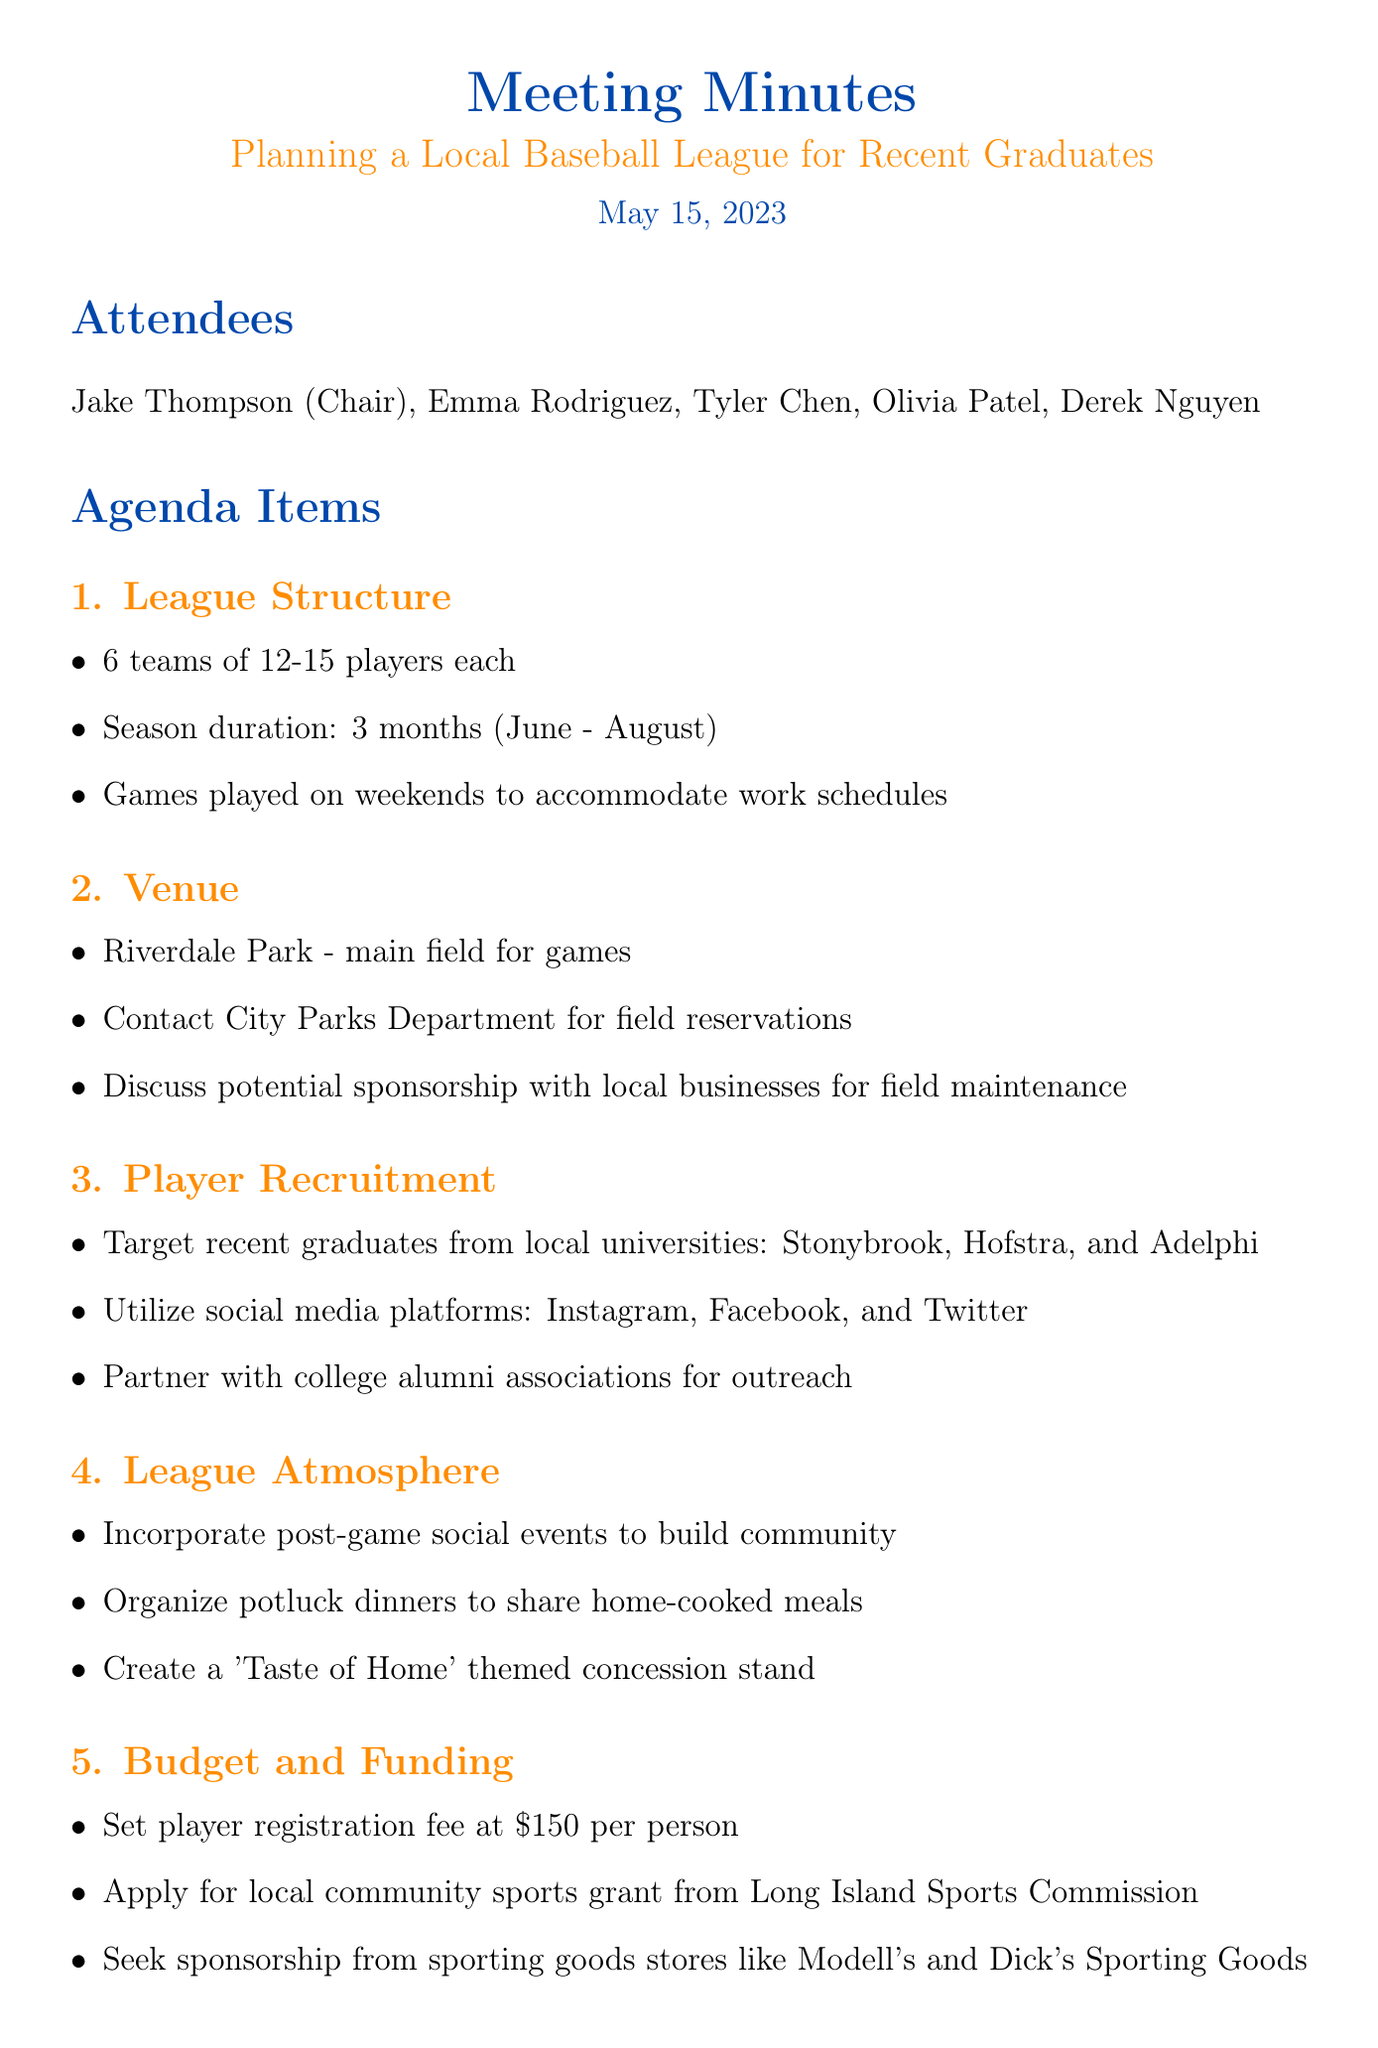What is the title of the meeting? The title of the meeting is specified at the top of the document, which is focused on planning a local baseball league.
Answer: Planning a Local Baseball League for Recent Graduates When will the season last? The document states the season duration, which is outlined in the league structure section.
Answer: 3 months How many players will each team have? The number of players per team is listed under the league structure section of the document.
Answer: 12-15 players Which park will be the main venue for games? The main field for games is mentioned in the venue section of the document.
Answer: Riverdale Park What is the player registration fee? The budget and funding section specifies the fee for players registering for the league.
Answer: $150 Who is responsible for drafting league rules? The "Next Steps" section lists the tasks assigned to different attendees, including drafting league rules.
Answer: Emma What kind of events will be organized after the games? The league atmosphere section describes social activities planned to strengthen community ties.
Answer: Post-game social events Which social media platforms will be utilized for player recruitment? The document mentions specific platforms for recruitment in the player recruitment section.
Answer: Instagram, Facebook, and Twitter What is one of the themes for the concession stand? The league atmosphere section provides specific themes for the concession stand that reflects a sense of community.
Answer: Taste of Home 